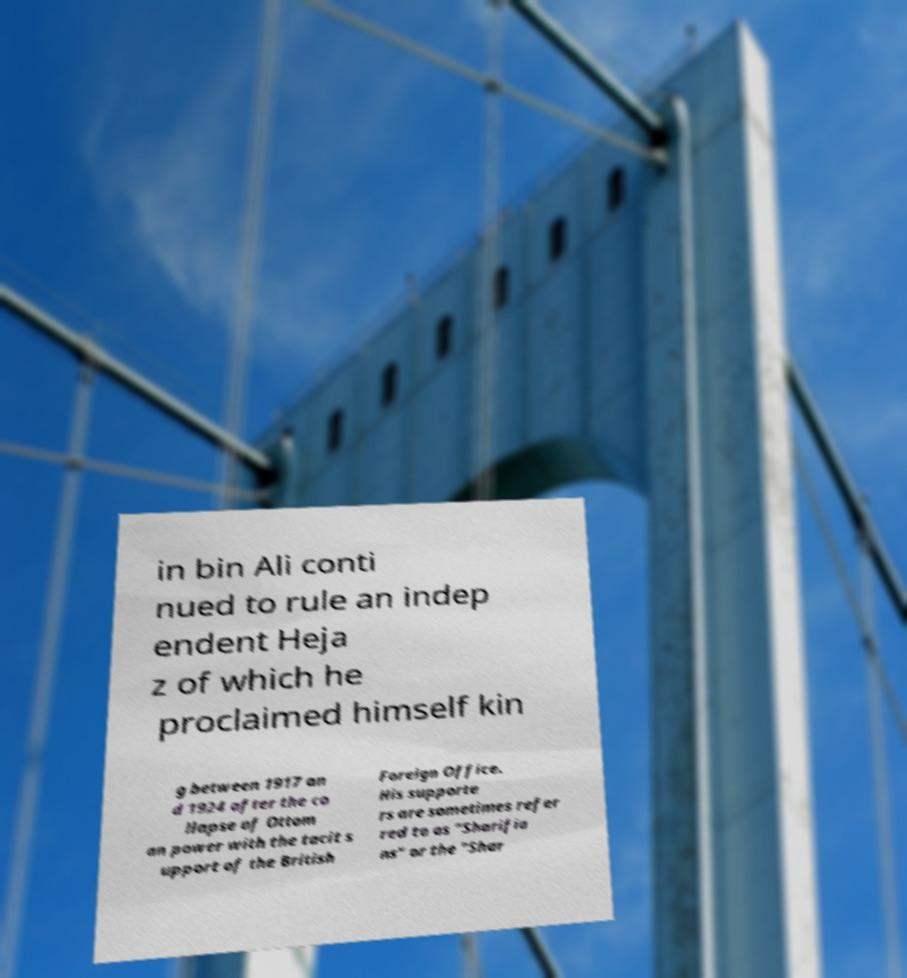Can you accurately transcribe the text from the provided image for me? in bin Ali conti nued to rule an indep endent Heja z of which he proclaimed himself kin g between 1917 an d 1924 after the co llapse of Ottom an power with the tacit s upport of the British Foreign Office. His supporte rs are sometimes refer red to as "Sharifia ns" or the "Shar 